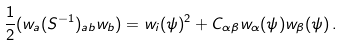<formula> <loc_0><loc_0><loc_500><loc_500>\frac { 1 } { 2 } ( w _ { a } ( S ^ { - 1 } ) _ { a b } w _ { b } ) = w _ { i } ( \psi ) ^ { 2 } + C _ { \alpha \beta } w _ { \alpha } ( \psi ) w _ { \beta } ( \psi ) \, .</formula> 